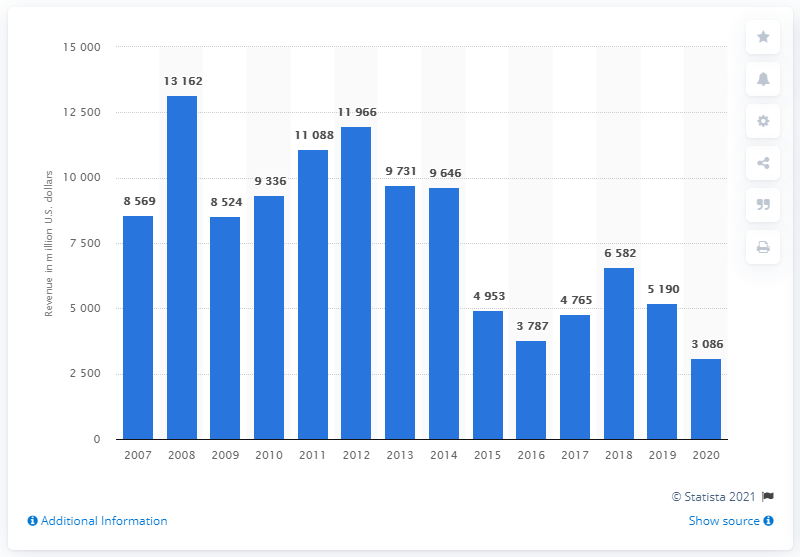Indicate a few pertinent items in this graphic. In 2020, Marathon Oil Corporation generated approximately $3086 million in revenue. 